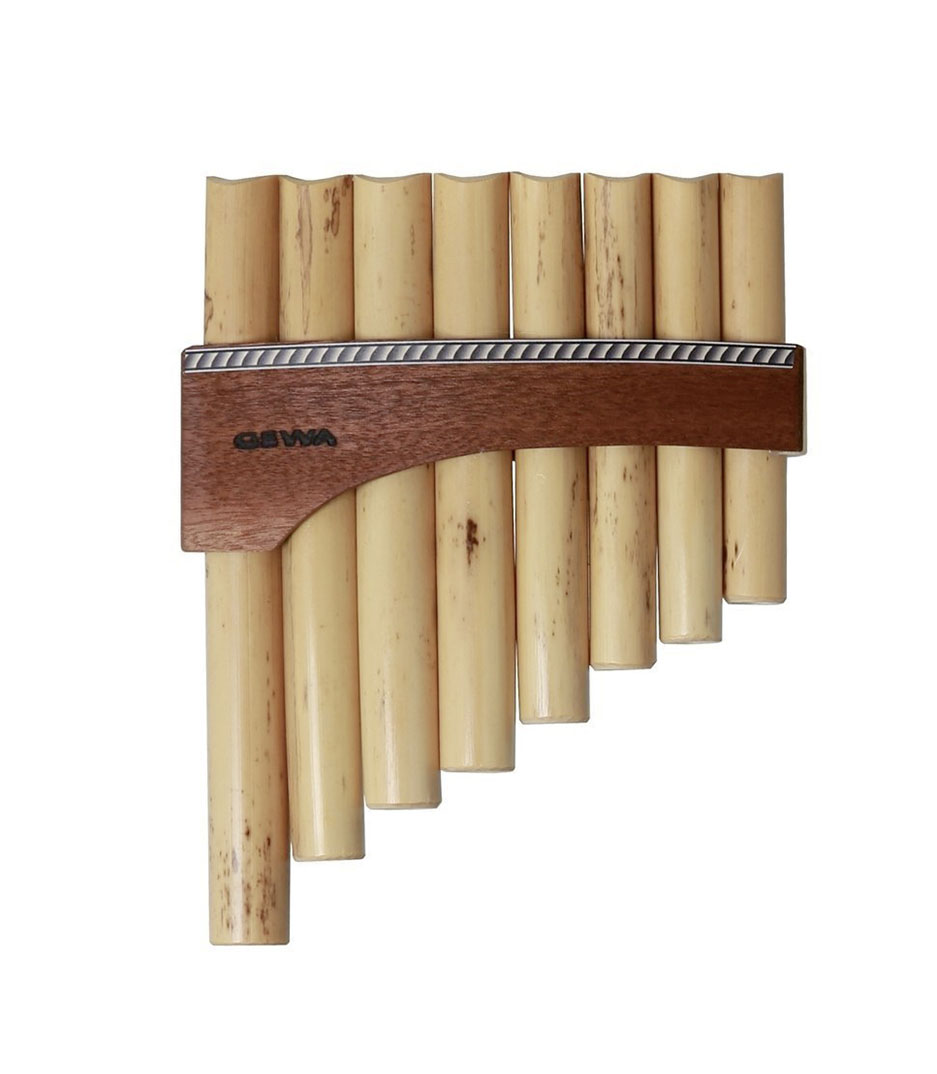What kind of sounds can this pan flute create? This pan flute is capable of producing a wide range of sounds, from the deep, resonant tones of the longer pipes to the bright, piercing notes of the shorter ones. Its melodies can be both hauntingly beautiful and joyfully lively, making it versatile in various musical genres. Its sound can mimic the gentle whisper of the wind, the melodic call of birds at dawn, or even the rhythmic cadence of raindrops. The unique timbre of each pipe allows the player to explore a rich tapestry of aural textures, creating music that can evoke profound emotions and vivid imagery. How do you think this pan flute was made? This pan flute was likely crafted by an artisan with deep knowledge and respect for musical traditions. The pipes are probably made from carefully selected bamboo or reed, known for their excellent acoustic properties. Each pipe was likely cut to a precise length, with its internal diameter carefully adjusted to ensure the correct pitch. The pipes were then bound together using a sturdy yet flexible material, allowing the instrument to be held comfortably. Lastly, the entire structure was finished with a protective coating, enhancing its durability and adding a touch of aesthetic beauty. Such craftsmanship results in an instrument that is not only functional but also a work of art in itself. 